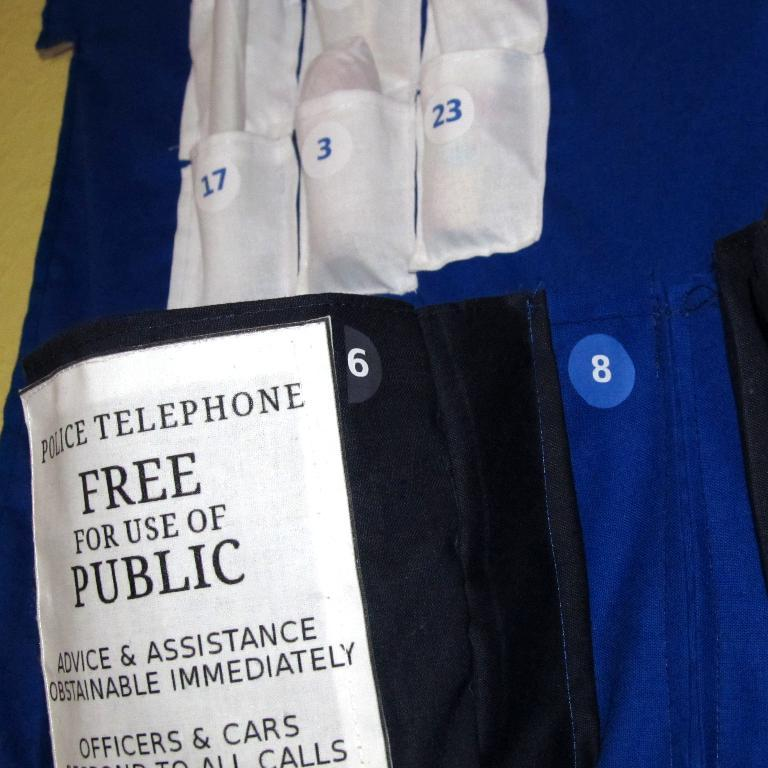What type of clothing is featured in the image? There is a dress in the image. What distinguishing features can be seen on the dress? The dress has numbers on it and text written on it. What is visible in the background of the image? There is a wall visible at the back of the image. How many trees are depicted on the dress in the image? There are no trees depicted on the dress; it features numbers and text. What does the son of the person wearing the dress look like? There is no information about a son or any person wearing the dress in the image. 